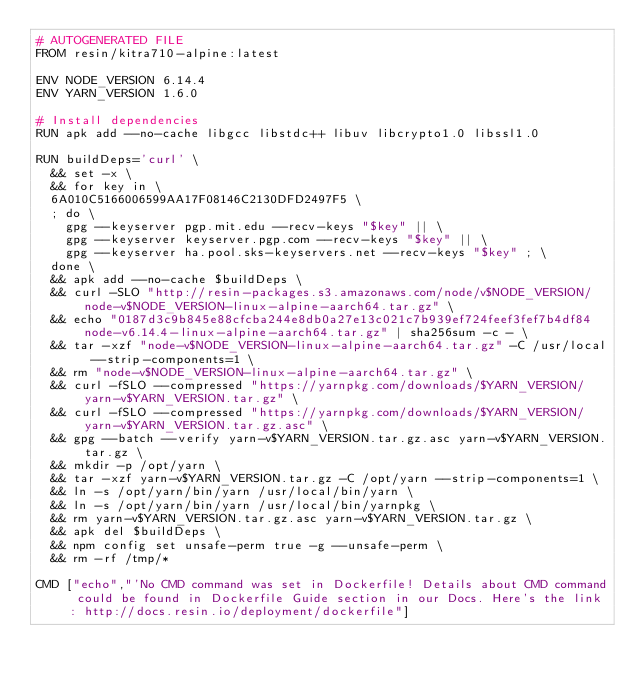Convert code to text. <code><loc_0><loc_0><loc_500><loc_500><_Dockerfile_># AUTOGENERATED FILE
FROM resin/kitra710-alpine:latest

ENV NODE_VERSION 6.14.4
ENV YARN_VERSION 1.6.0

# Install dependencies
RUN apk add --no-cache libgcc libstdc++ libuv libcrypto1.0 libssl1.0

RUN buildDeps='curl' \
	&& set -x \
	&& for key in \
	6A010C5166006599AA17F08146C2130DFD2497F5 \
	; do \
		gpg --keyserver pgp.mit.edu --recv-keys "$key" || \
		gpg --keyserver keyserver.pgp.com --recv-keys "$key" || \
		gpg --keyserver ha.pool.sks-keyservers.net --recv-keys "$key" ; \
	done \
	&& apk add --no-cache $buildDeps \
	&& curl -SLO "http://resin-packages.s3.amazonaws.com/node/v$NODE_VERSION/node-v$NODE_VERSION-linux-alpine-aarch64.tar.gz" \
	&& echo "0187d3c9b845e88cfcba244e8db0a27e13c021c7b939ef724feef3fef7b4df84  node-v6.14.4-linux-alpine-aarch64.tar.gz" | sha256sum -c - \
	&& tar -xzf "node-v$NODE_VERSION-linux-alpine-aarch64.tar.gz" -C /usr/local --strip-components=1 \
	&& rm "node-v$NODE_VERSION-linux-alpine-aarch64.tar.gz" \
	&& curl -fSLO --compressed "https://yarnpkg.com/downloads/$YARN_VERSION/yarn-v$YARN_VERSION.tar.gz" \
	&& curl -fSLO --compressed "https://yarnpkg.com/downloads/$YARN_VERSION/yarn-v$YARN_VERSION.tar.gz.asc" \
	&& gpg --batch --verify yarn-v$YARN_VERSION.tar.gz.asc yarn-v$YARN_VERSION.tar.gz \
	&& mkdir -p /opt/yarn \
	&& tar -xzf yarn-v$YARN_VERSION.tar.gz -C /opt/yarn --strip-components=1 \
	&& ln -s /opt/yarn/bin/yarn /usr/local/bin/yarn \
	&& ln -s /opt/yarn/bin/yarn /usr/local/bin/yarnpkg \
	&& rm yarn-v$YARN_VERSION.tar.gz.asc yarn-v$YARN_VERSION.tar.gz \
	&& apk del $buildDeps \
	&& npm config set unsafe-perm true -g --unsafe-perm \
	&& rm -rf /tmp/*

CMD ["echo","'No CMD command was set in Dockerfile! Details about CMD command could be found in Dockerfile Guide section in our Docs. Here's the link: http://docs.resin.io/deployment/dockerfile"]
</code> 